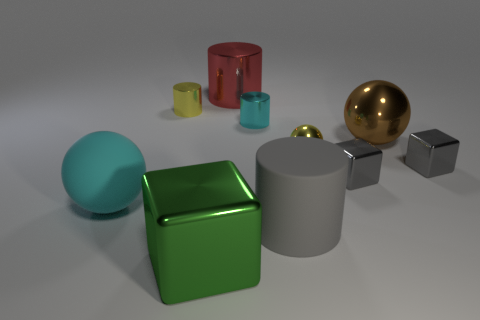Are there fewer big brown balls in front of the cyan metallic cylinder than small shiny cubes in front of the large brown thing?
Your answer should be compact. Yes. There is a tiny ball that is made of the same material as the red cylinder; what color is it?
Your answer should be very brief. Yellow. Is there a big cylinder that is in front of the metal ball that is behind the tiny yellow ball?
Your answer should be compact. Yes. What color is the shiny sphere that is the same size as the yellow cylinder?
Your response must be concise. Yellow. What number of objects are matte things or large brown cubes?
Provide a succinct answer. 2. There is a ball in front of the yellow shiny sphere to the left of the sphere that is right of the yellow ball; how big is it?
Offer a very short reply. Large. What number of things are the same color as the large rubber ball?
Ensure brevity in your answer.  1. What number of tiny cylinders are made of the same material as the big cyan thing?
Your answer should be compact. 0. How many things are cubes or matte objects that are to the right of the large green metal thing?
Your answer should be very brief. 4. What color is the rubber thing left of the metal cube that is to the left of the big rubber cylinder that is to the right of the big matte ball?
Provide a short and direct response. Cyan. 